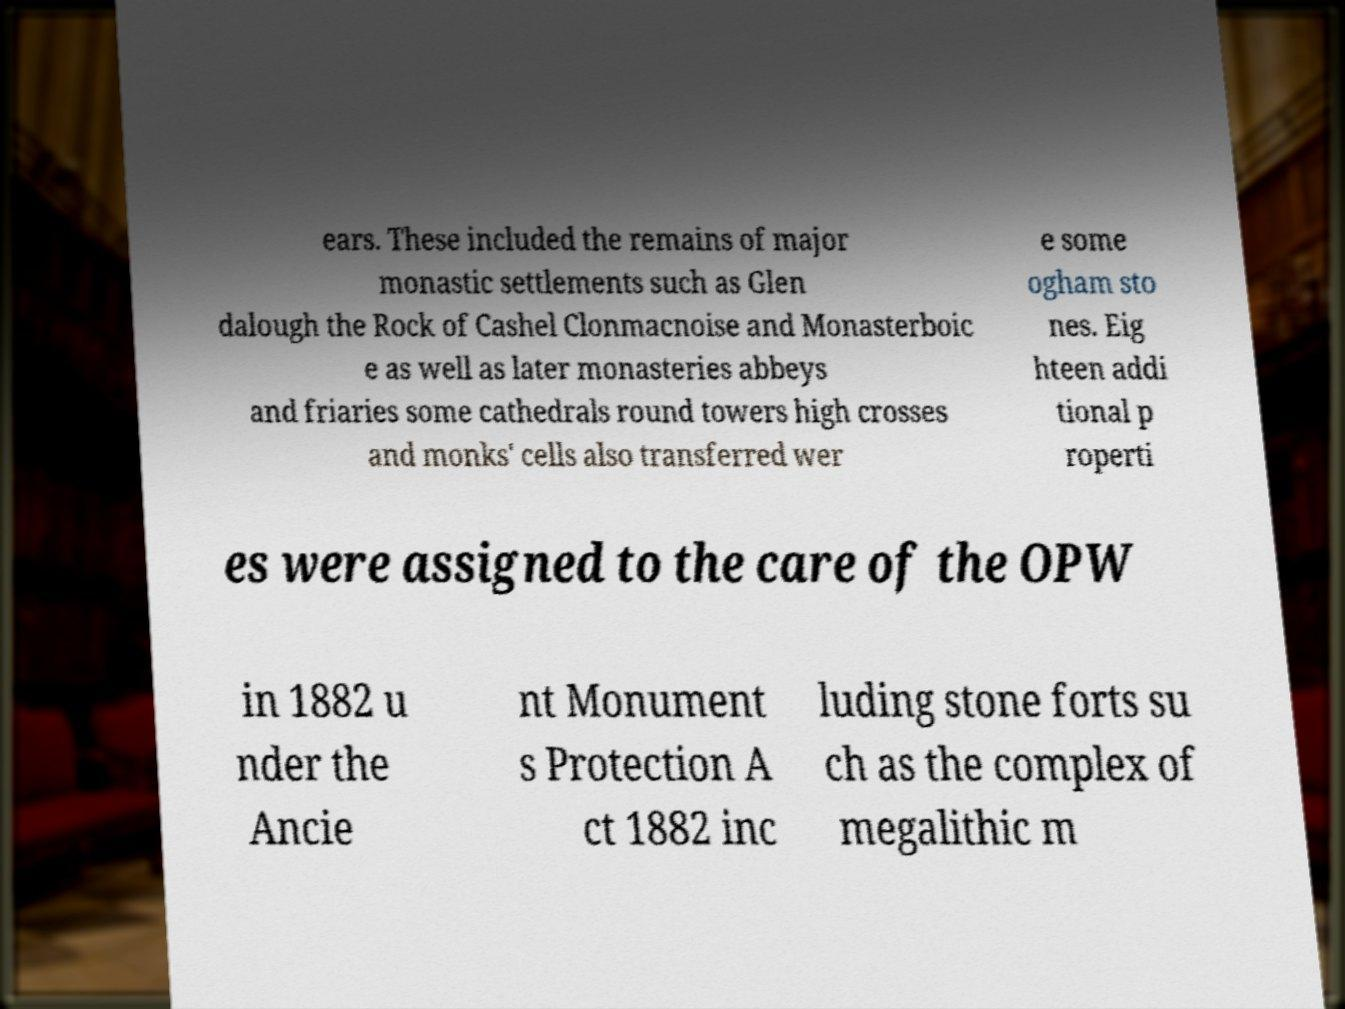Please identify and transcribe the text found in this image. ears. These included the remains of major monastic settlements such as Glen dalough the Rock of Cashel Clonmacnoise and Monasterboic e as well as later monasteries abbeys and friaries some cathedrals round towers high crosses and monks' cells also transferred wer e some ogham sto nes. Eig hteen addi tional p roperti es were assigned to the care of the OPW in 1882 u nder the Ancie nt Monument s Protection A ct 1882 inc luding stone forts su ch as the complex of megalithic m 